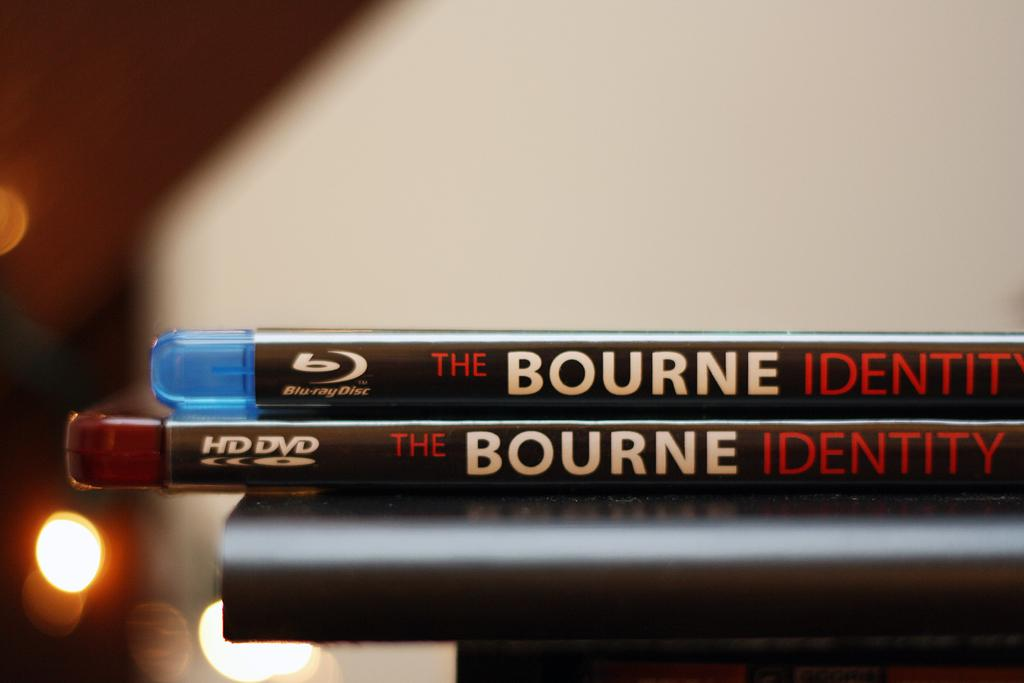<image>
Write a terse but informative summary of the picture. a dvd and blue ray of the bourne identity 